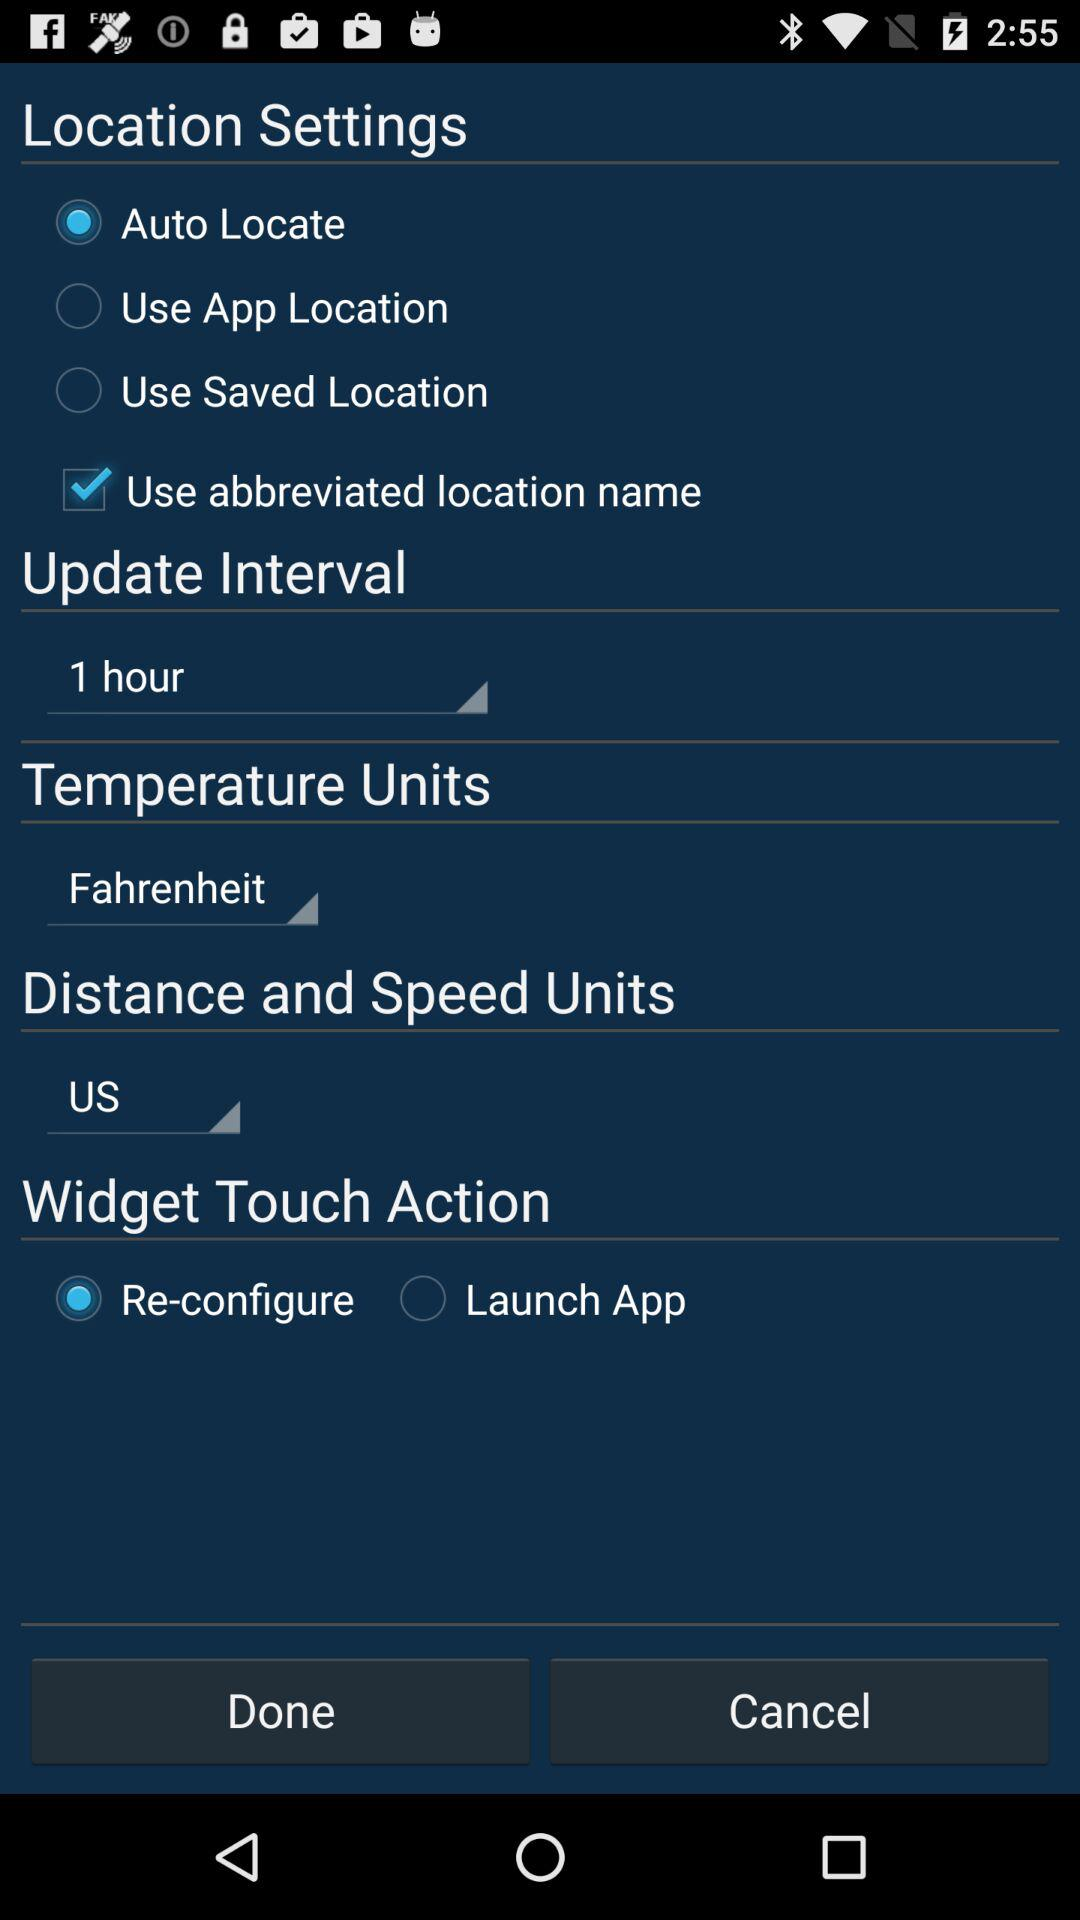What is the unit of temperature? The unit of temperature is Fahrenheit. 